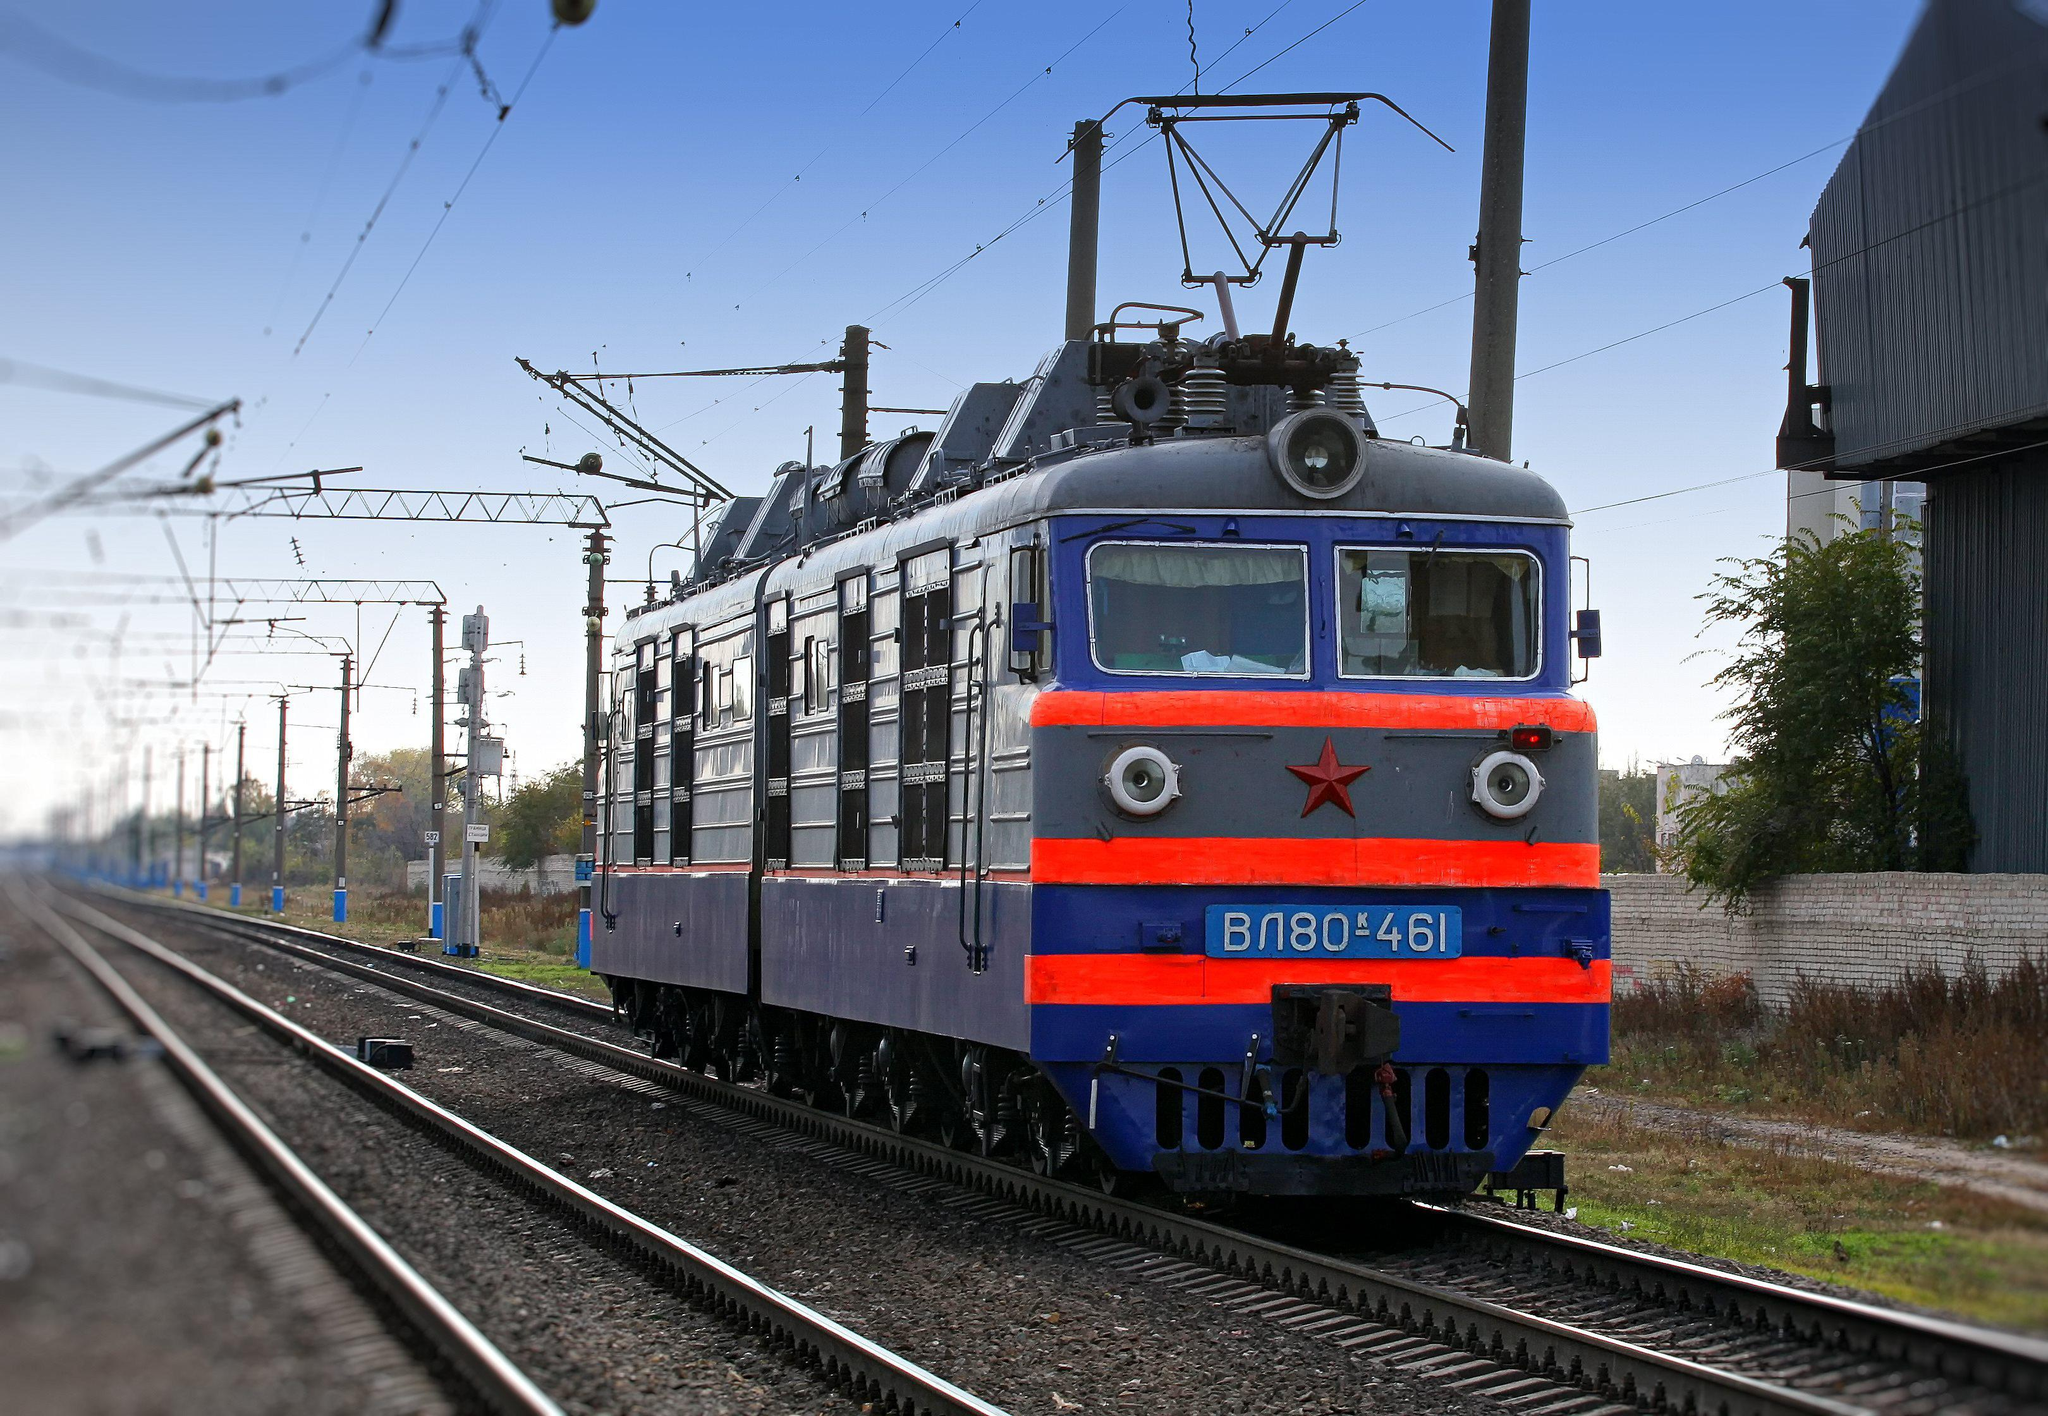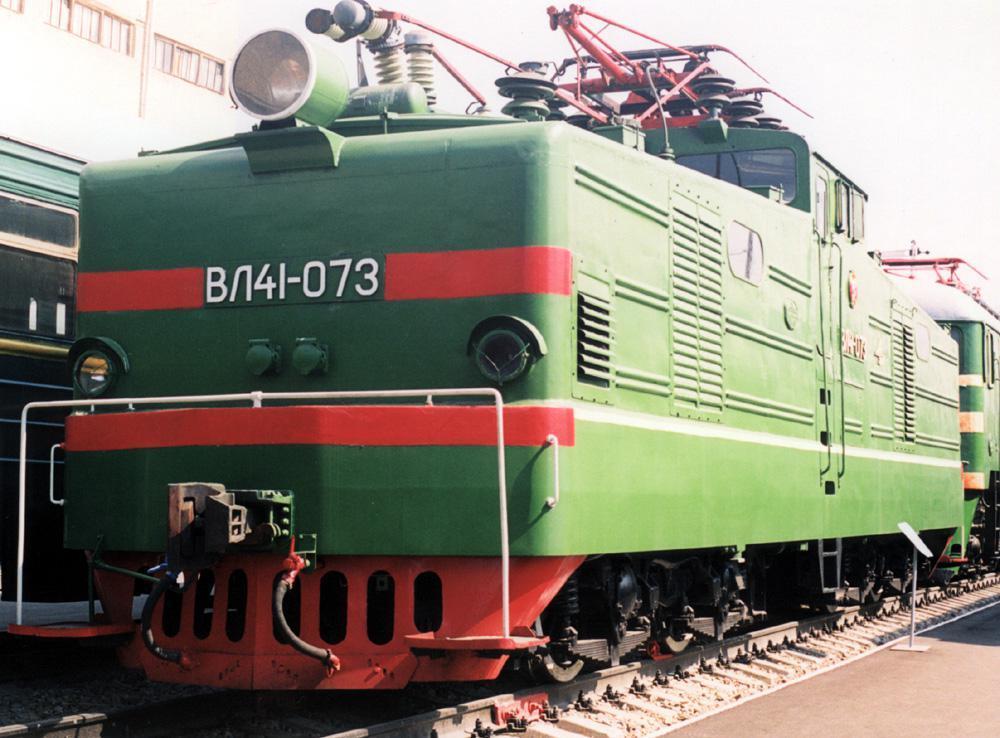The first image is the image on the left, the second image is the image on the right. Evaluate the accuracy of this statement regarding the images: "There are three red stripes on the front of the train in the image on the left.". Is it true? Answer yes or no. Yes. 